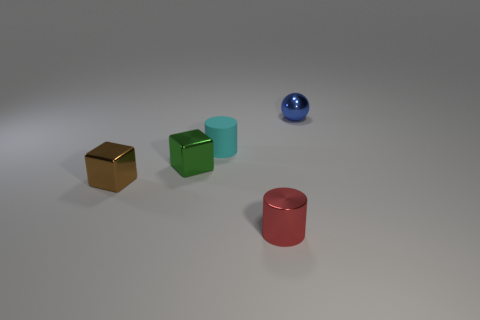Does the tiny thing that is in front of the tiny brown thing have the same material as the cyan object?
Keep it short and to the point. No. What material is the tiny cylinder that is behind the shiny cylinder?
Provide a short and direct response. Rubber. How many other things are there of the same shape as the blue shiny thing?
Provide a short and direct response. 0. Is the material of the tiny object that is in front of the brown metallic block the same as the block that is left of the green thing?
Offer a very short reply. Yes. There is a small metallic thing that is both behind the small red metal cylinder and on the right side of the cyan rubber cylinder; what shape is it?
Keep it short and to the point. Sphere. Are there any other things that are the same material as the tiny cyan cylinder?
Offer a very short reply. No. What is the small thing that is in front of the tiny cyan matte cylinder and behind the small brown object made of?
Provide a succinct answer. Metal. What shape is the tiny green thing that is the same material as the small red thing?
Keep it short and to the point. Cube. Is the number of metallic things that are right of the small matte cylinder greater than the number of red things?
Make the answer very short. Yes. What is the small blue object made of?
Make the answer very short. Metal. 